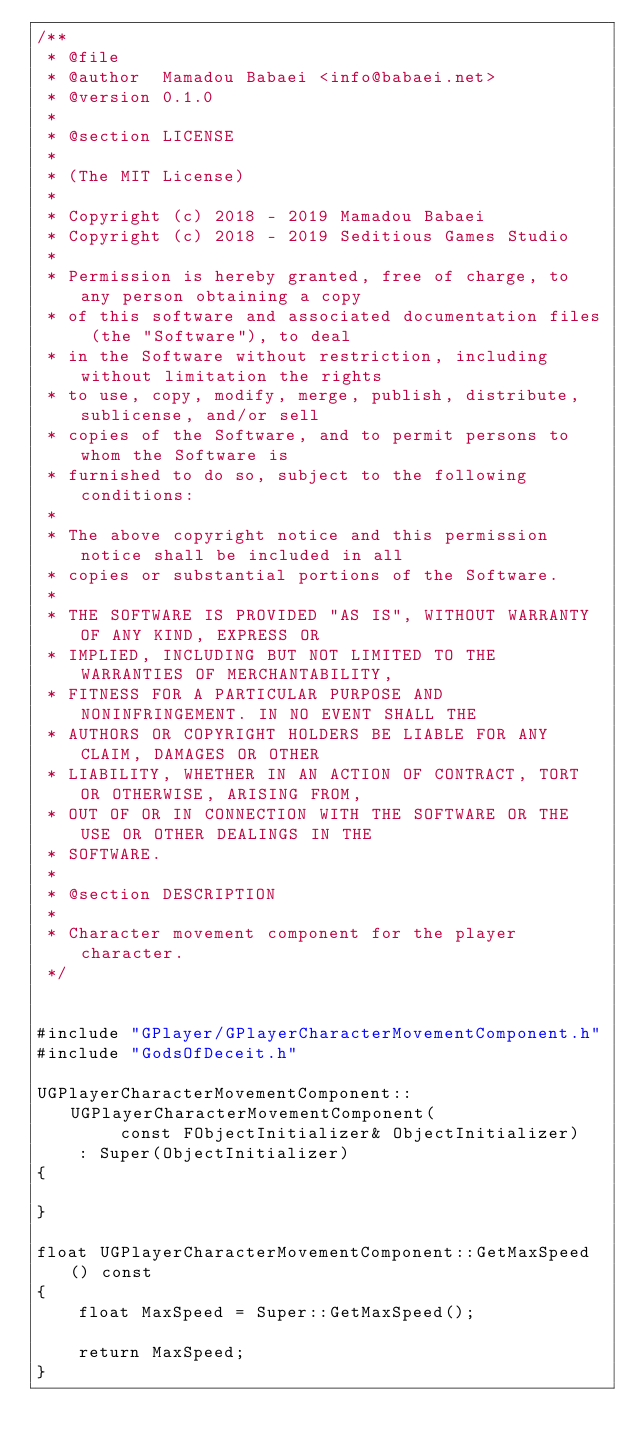<code> <loc_0><loc_0><loc_500><loc_500><_C++_>/**
 * @file
 * @author  Mamadou Babaei <info@babaei.net>
 * @version 0.1.0
 *
 * @section LICENSE
 *
 * (The MIT License)
 *
 * Copyright (c) 2018 - 2019 Mamadou Babaei
 * Copyright (c) 2018 - 2019 Seditious Games Studio
 *
 * Permission is hereby granted, free of charge, to any person obtaining a copy
 * of this software and associated documentation files (the "Software"), to deal
 * in the Software without restriction, including without limitation the rights
 * to use, copy, modify, merge, publish, distribute, sublicense, and/or sell
 * copies of the Software, and to permit persons to whom the Software is
 * furnished to do so, subject to the following conditions:
 *
 * The above copyright notice and this permission notice shall be included in all
 * copies or substantial portions of the Software.
 *
 * THE SOFTWARE IS PROVIDED "AS IS", WITHOUT WARRANTY OF ANY KIND, EXPRESS OR
 * IMPLIED, INCLUDING BUT NOT LIMITED TO THE WARRANTIES OF MERCHANTABILITY,
 * FITNESS FOR A PARTICULAR PURPOSE AND NONINFRINGEMENT. IN NO EVENT SHALL THE
 * AUTHORS OR COPYRIGHT HOLDERS BE LIABLE FOR ANY CLAIM, DAMAGES OR OTHER
 * LIABILITY, WHETHER IN AN ACTION OF CONTRACT, TORT OR OTHERWISE, ARISING FROM,
 * OUT OF OR IN CONNECTION WITH THE SOFTWARE OR THE USE OR OTHER DEALINGS IN THE
 * SOFTWARE.
 *
 * @section DESCRIPTION
 *
 * Character movement component for the player character.
 */


#include "GPlayer/GPlayerCharacterMovementComponent.h"
#include "GodsOfDeceit.h"

UGPlayerCharacterMovementComponent::UGPlayerCharacterMovementComponent(
        const FObjectInitializer& ObjectInitializer)
    : Super(ObjectInitializer)
{

}

float UGPlayerCharacterMovementComponent::GetMaxSpeed() const
{
    float MaxSpeed = Super::GetMaxSpeed();

    return MaxSpeed;
}
</code> 